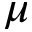<formula> <loc_0><loc_0><loc_500><loc_500>\mu</formula> 